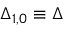Convert formula to latex. <formula><loc_0><loc_0><loc_500><loc_500>\Delta _ { 1 , 0 } \equiv \Delta</formula> 